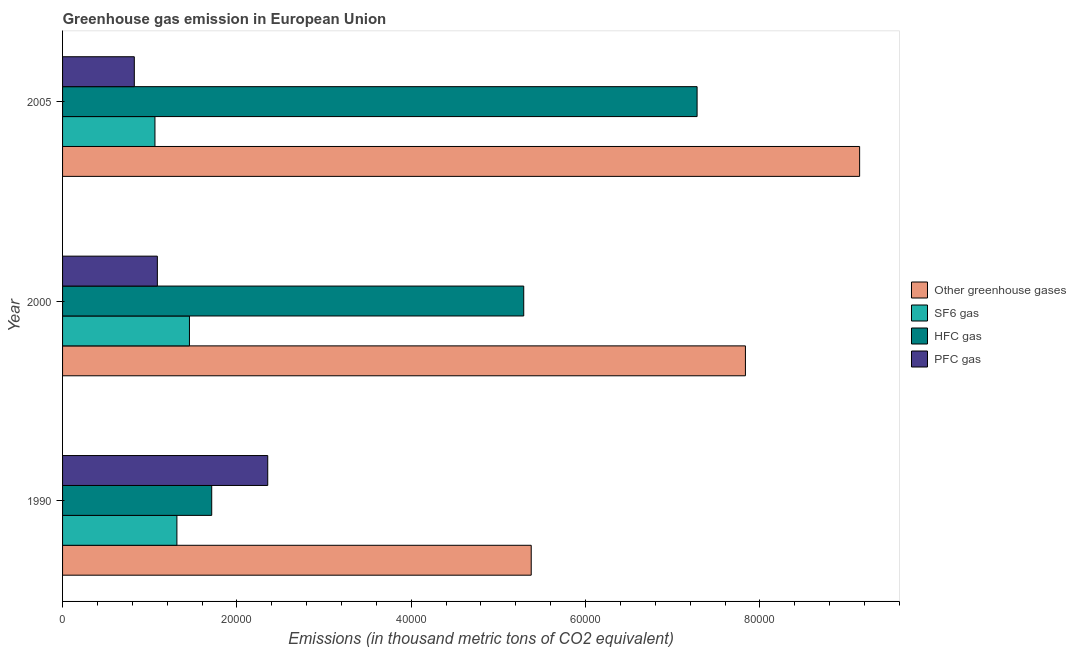How many different coloured bars are there?
Offer a very short reply. 4. Are the number of bars per tick equal to the number of legend labels?
Provide a short and direct response. Yes. Are the number of bars on each tick of the Y-axis equal?
Provide a short and direct response. Yes. What is the label of the 2nd group of bars from the top?
Provide a succinct answer. 2000. What is the emission of sf6 gas in 2005?
Keep it short and to the point. 1.06e+04. Across all years, what is the maximum emission of pfc gas?
Offer a very short reply. 2.35e+04. Across all years, what is the minimum emission of pfc gas?
Offer a terse response. 8230.79. In which year was the emission of hfc gas maximum?
Your answer should be very brief. 2005. In which year was the emission of greenhouse gases minimum?
Offer a terse response. 1990. What is the total emission of pfc gas in the graph?
Your answer should be very brief. 4.26e+04. What is the difference between the emission of pfc gas in 1990 and that in 2000?
Provide a short and direct response. 1.27e+04. What is the difference between the emission of hfc gas in 2000 and the emission of greenhouse gases in 1990?
Provide a short and direct response. -859.6. What is the average emission of pfc gas per year?
Make the answer very short. 1.42e+04. In the year 1990, what is the difference between the emission of hfc gas and emission of sf6 gas?
Your answer should be very brief. 3993.7. What is the ratio of the emission of pfc gas in 2000 to that in 2005?
Offer a very short reply. 1.32. What is the difference between the highest and the second highest emission of greenhouse gases?
Provide a short and direct response. 1.31e+04. What is the difference between the highest and the lowest emission of sf6 gas?
Your answer should be compact. 3958.08. Is it the case that in every year, the sum of the emission of greenhouse gases and emission of pfc gas is greater than the sum of emission of sf6 gas and emission of hfc gas?
Ensure brevity in your answer.  No. What does the 4th bar from the top in 2005 represents?
Your response must be concise. Other greenhouse gases. What does the 1st bar from the bottom in 2000 represents?
Ensure brevity in your answer.  Other greenhouse gases. Is it the case that in every year, the sum of the emission of greenhouse gases and emission of sf6 gas is greater than the emission of hfc gas?
Ensure brevity in your answer.  Yes. Are all the bars in the graph horizontal?
Provide a succinct answer. Yes. How many years are there in the graph?
Keep it short and to the point. 3. Does the graph contain grids?
Provide a succinct answer. No. How many legend labels are there?
Give a very brief answer. 4. How are the legend labels stacked?
Offer a very short reply. Vertical. What is the title of the graph?
Offer a terse response. Greenhouse gas emission in European Union. What is the label or title of the X-axis?
Your answer should be very brief. Emissions (in thousand metric tons of CO2 equivalent). What is the Emissions (in thousand metric tons of CO2 equivalent) in Other greenhouse gases in 1990?
Offer a terse response. 5.38e+04. What is the Emissions (in thousand metric tons of CO2 equivalent) in SF6 gas in 1990?
Your response must be concise. 1.31e+04. What is the Emissions (in thousand metric tons of CO2 equivalent) of HFC gas in 1990?
Your answer should be very brief. 1.71e+04. What is the Emissions (in thousand metric tons of CO2 equivalent) of PFC gas in 1990?
Provide a short and direct response. 2.35e+04. What is the Emissions (in thousand metric tons of CO2 equivalent) in Other greenhouse gases in 2000?
Your response must be concise. 7.83e+04. What is the Emissions (in thousand metric tons of CO2 equivalent) of SF6 gas in 2000?
Offer a terse response. 1.46e+04. What is the Emissions (in thousand metric tons of CO2 equivalent) in HFC gas in 2000?
Keep it short and to the point. 5.29e+04. What is the Emissions (in thousand metric tons of CO2 equivalent) in PFC gas in 2000?
Your answer should be very brief. 1.09e+04. What is the Emissions (in thousand metric tons of CO2 equivalent) of Other greenhouse gases in 2005?
Offer a very short reply. 9.14e+04. What is the Emissions (in thousand metric tons of CO2 equivalent) of SF6 gas in 2005?
Your response must be concise. 1.06e+04. What is the Emissions (in thousand metric tons of CO2 equivalent) of HFC gas in 2005?
Ensure brevity in your answer.  7.28e+04. What is the Emissions (in thousand metric tons of CO2 equivalent) of PFC gas in 2005?
Your answer should be compact. 8230.79. Across all years, what is the maximum Emissions (in thousand metric tons of CO2 equivalent) in Other greenhouse gases?
Provide a short and direct response. 9.14e+04. Across all years, what is the maximum Emissions (in thousand metric tons of CO2 equivalent) in SF6 gas?
Provide a succinct answer. 1.46e+04. Across all years, what is the maximum Emissions (in thousand metric tons of CO2 equivalent) of HFC gas?
Offer a very short reply. 7.28e+04. Across all years, what is the maximum Emissions (in thousand metric tons of CO2 equivalent) in PFC gas?
Keep it short and to the point. 2.35e+04. Across all years, what is the minimum Emissions (in thousand metric tons of CO2 equivalent) in Other greenhouse gases?
Give a very brief answer. 5.38e+04. Across all years, what is the minimum Emissions (in thousand metric tons of CO2 equivalent) of SF6 gas?
Your response must be concise. 1.06e+04. Across all years, what is the minimum Emissions (in thousand metric tons of CO2 equivalent) in HFC gas?
Your response must be concise. 1.71e+04. Across all years, what is the minimum Emissions (in thousand metric tons of CO2 equivalent) of PFC gas?
Provide a short and direct response. 8230.79. What is the total Emissions (in thousand metric tons of CO2 equivalent) of Other greenhouse gases in the graph?
Make the answer very short. 2.24e+05. What is the total Emissions (in thousand metric tons of CO2 equivalent) in SF6 gas in the graph?
Make the answer very short. 3.83e+04. What is the total Emissions (in thousand metric tons of CO2 equivalent) of HFC gas in the graph?
Ensure brevity in your answer.  1.43e+05. What is the total Emissions (in thousand metric tons of CO2 equivalent) of PFC gas in the graph?
Your answer should be very brief. 4.26e+04. What is the difference between the Emissions (in thousand metric tons of CO2 equivalent) in Other greenhouse gases in 1990 and that in 2000?
Provide a succinct answer. -2.46e+04. What is the difference between the Emissions (in thousand metric tons of CO2 equivalent) in SF6 gas in 1990 and that in 2000?
Your response must be concise. -1440.2. What is the difference between the Emissions (in thousand metric tons of CO2 equivalent) in HFC gas in 1990 and that in 2000?
Provide a succinct answer. -3.58e+04. What is the difference between the Emissions (in thousand metric tons of CO2 equivalent) in PFC gas in 1990 and that in 2000?
Make the answer very short. 1.27e+04. What is the difference between the Emissions (in thousand metric tons of CO2 equivalent) in Other greenhouse gases in 1990 and that in 2005?
Your answer should be compact. -3.77e+04. What is the difference between the Emissions (in thousand metric tons of CO2 equivalent) in SF6 gas in 1990 and that in 2005?
Provide a short and direct response. 2517.88. What is the difference between the Emissions (in thousand metric tons of CO2 equivalent) of HFC gas in 1990 and that in 2005?
Provide a succinct answer. -5.57e+04. What is the difference between the Emissions (in thousand metric tons of CO2 equivalent) of PFC gas in 1990 and that in 2005?
Your response must be concise. 1.53e+04. What is the difference between the Emissions (in thousand metric tons of CO2 equivalent) in Other greenhouse gases in 2000 and that in 2005?
Your answer should be compact. -1.31e+04. What is the difference between the Emissions (in thousand metric tons of CO2 equivalent) in SF6 gas in 2000 and that in 2005?
Give a very brief answer. 3958.08. What is the difference between the Emissions (in thousand metric tons of CO2 equivalent) in HFC gas in 2000 and that in 2005?
Provide a short and direct response. -1.99e+04. What is the difference between the Emissions (in thousand metric tons of CO2 equivalent) in PFC gas in 2000 and that in 2005?
Your answer should be compact. 2643.81. What is the difference between the Emissions (in thousand metric tons of CO2 equivalent) in Other greenhouse gases in 1990 and the Emissions (in thousand metric tons of CO2 equivalent) in SF6 gas in 2000?
Provide a short and direct response. 3.92e+04. What is the difference between the Emissions (in thousand metric tons of CO2 equivalent) of Other greenhouse gases in 1990 and the Emissions (in thousand metric tons of CO2 equivalent) of HFC gas in 2000?
Provide a succinct answer. 859.6. What is the difference between the Emissions (in thousand metric tons of CO2 equivalent) of Other greenhouse gases in 1990 and the Emissions (in thousand metric tons of CO2 equivalent) of PFC gas in 2000?
Your answer should be compact. 4.29e+04. What is the difference between the Emissions (in thousand metric tons of CO2 equivalent) of SF6 gas in 1990 and the Emissions (in thousand metric tons of CO2 equivalent) of HFC gas in 2000?
Offer a very short reply. -3.98e+04. What is the difference between the Emissions (in thousand metric tons of CO2 equivalent) of SF6 gas in 1990 and the Emissions (in thousand metric tons of CO2 equivalent) of PFC gas in 2000?
Offer a terse response. 2241.9. What is the difference between the Emissions (in thousand metric tons of CO2 equivalent) in HFC gas in 1990 and the Emissions (in thousand metric tons of CO2 equivalent) in PFC gas in 2000?
Your answer should be very brief. 6235.6. What is the difference between the Emissions (in thousand metric tons of CO2 equivalent) of Other greenhouse gases in 1990 and the Emissions (in thousand metric tons of CO2 equivalent) of SF6 gas in 2005?
Provide a short and direct response. 4.32e+04. What is the difference between the Emissions (in thousand metric tons of CO2 equivalent) of Other greenhouse gases in 1990 and the Emissions (in thousand metric tons of CO2 equivalent) of HFC gas in 2005?
Provide a succinct answer. -1.90e+04. What is the difference between the Emissions (in thousand metric tons of CO2 equivalent) in Other greenhouse gases in 1990 and the Emissions (in thousand metric tons of CO2 equivalent) in PFC gas in 2005?
Keep it short and to the point. 4.55e+04. What is the difference between the Emissions (in thousand metric tons of CO2 equivalent) in SF6 gas in 1990 and the Emissions (in thousand metric tons of CO2 equivalent) in HFC gas in 2005?
Offer a terse response. -5.97e+04. What is the difference between the Emissions (in thousand metric tons of CO2 equivalent) of SF6 gas in 1990 and the Emissions (in thousand metric tons of CO2 equivalent) of PFC gas in 2005?
Keep it short and to the point. 4885.71. What is the difference between the Emissions (in thousand metric tons of CO2 equivalent) of HFC gas in 1990 and the Emissions (in thousand metric tons of CO2 equivalent) of PFC gas in 2005?
Your response must be concise. 8879.41. What is the difference between the Emissions (in thousand metric tons of CO2 equivalent) in Other greenhouse gases in 2000 and the Emissions (in thousand metric tons of CO2 equivalent) in SF6 gas in 2005?
Make the answer very short. 6.77e+04. What is the difference between the Emissions (in thousand metric tons of CO2 equivalent) in Other greenhouse gases in 2000 and the Emissions (in thousand metric tons of CO2 equivalent) in HFC gas in 2005?
Make the answer very short. 5543.7. What is the difference between the Emissions (in thousand metric tons of CO2 equivalent) in Other greenhouse gases in 2000 and the Emissions (in thousand metric tons of CO2 equivalent) in PFC gas in 2005?
Make the answer very short. 7.01e+04. What is the difference between the Emissions (in thousand metric tons of CO2 equivalent) in SF6 gas in 2000 and the Emissions (in thousand metric tons of CO2 equivalent) in HFC gas in 2005?
Make the answer very short. -5.82e+04. What is the difference between the Emissions (in thousand metric tons of CO2 equivalent) in SF6 gas in 2000 and the Emissions (in thousand metric tons of CO2 equivalent) in PFC gas in 2005?
Your response must be concise. 6325.91. What is the difference between the Emissions (in thousand metric tons of CO2 equivalent) of HFC gas in 2000 and the Emissions (in thousand metric tons of CO2 equivalent) of PFC gas in 2005?
Provide a short and direct response. 4.47e+04. What is the average Emissions (in thousand metric tons of CO2 equivalent) in Other greenhouse gases per year?
Provide a short and direct response. 7.45e+04. What is the average Emissions (in thousand metric tons of CO2 equivalent) of SF6 gas per year?
Your answer should be very brief. 1.28e+04. What is the average Emissions (in thousand metric tons of CO2 equivalent) in HFC gas per year?
Provide a short and direct response. 4.76e+04. What is the average Emissions (in thousand metric tons of CO2 equivalent) of PFC gas per year?
Offer a terse response. 1.42e+04. In the year 1990, what is the difference between the Emissions (in thousand metric tons of CO2 equivalent) of Other greenhouse gases and Emissions (in thousand metric tons of CO2 equivalent) of SF6 gas?
Provide a short and direct response. 4.06e+04. In the year 1990, what is the difference between the Emissions (in thousand metric tons of CO2 equivalent) of Other greenhouse gases and Emissions (in thousand metric tons of CO2 equivalent) of HFC gas?
Ensure brevity in your answer.  3.67e+04. In the year 1990, what is the difference between the Emissions (in thousand metric tons of CO2 equivalent) of Other greenhouse gases and Emissions (in thousand metric tons of CO2 equivalent) of PFC gas?
Provide a succinct answer. 3.02e+04. In the year 1990, what is the difference between the Emissions (in thousand metric tons of CO2 equivalent) in SF6 gas and Emissions (in thousand metric tons of CO2 equivalent) in HFC gas?
Provide a short and direct response. -3993.7. In the year 1990, what is the difference between the Emissions (in thousand metric tons of CO2 equivalent) of SF6 gas and Emissions (in thousand metric tons of CO2 equivalent) of PFC gas?
Your answer should be very brief. -1.04e+04. In the year 1990, what is the difference between the Emissions (in thousand metric tons of CO2 equivalent) in HFC gas and Emissions (in thousand metric tons of CO2 equivalent) in PFC gas?
Provide a short and direct response. -6426.3. In the year 2000, what is the difference between the Emissions (in thousand metric tons of CO2 equivalent) of Other greenhouse gases and Emissions (in thousand metric tons of CO2 equivalent) of SF6 gas?
Make the answer very short. 6.38e+04. In the year 2000, what is the difference between the Emissions (in thousand metric tons of CO2 equivalent) in Other greenhouse gases and Emissions (in thousand metric tons of CO2 equivalent) in HFC gas?
Your response must be concise. 2.54e+04. In the year 2000, what is the difference between the Emissions (in thousand metric tons of CO2 equivalent) in Other greenhouse gases and Emissions (in thousand metric tons of CO2 equivalent) in PFC gas?
Offer a terse response. 6.75e+04. In the year 2000, what is the difference between the Emissions (in thousand metric tons of CO2 equivalent) of SF6 gas and Emissions (in thousand metric tons of CO2 equivalent) of HFC gas?
Provide a succinct answer. -3.83e+04. In the year 2000, what is the difference between the Emissions (in thousand metric tons of CO2 equivalent) of SF6 gas and Emissions (in thousand metric tons of CO2 equivalent) of PFC gas?
Give a very brief answer. 3682.1. In the year 2000, what is the difference between the Emissions (in thousand metric tons of CO2 equivalent) of HFC gas and Emissions (in thousand metric tons of CO2 equivalent) of PFC gas?
Give a very brief answer. 4.20e+04. In the year 2005, what is the difference between the Emissions (in thousand metric tons of CO2 equivalent) of Other greenhouse gases and Emissions (in thousand metric tons of CO2 equivalent) of SF6 gas?
Give a very brief answer. 8.08e+04. In the year 2005, what is the difference between the Emissions (in thousand metric tons of CO2 equivalent) in Other greenhouse gases and Emissions (in thousand metric tons of CO2 equivalent) in HFC gas?
Provide a succinct answer. 1.86e+04. In the year 2005, what is the difference between the Emissions (in thousand metric tons of CO2 equivalent) of Other greenhouse gases and Emissions (in thousand metric tons of CO2 equivalent) of PFC gas?
Keep it short and to the point. 8.32e+04. In the year 2005, what is the difference between the Emissions (in thousand metric tons of CO2 equivalent) of SF6 gas and Emissions (in thousand metric tons of CO2 equivalent) of HFC gas?
Your response must be concise. -6.22e+04. In the year 2005, what is the difference between the Emissions (in thousand metric tons of CO2 equivalent) in SF6 gas and Emissions (in thousand metric tons of CO2 equivalent) in PFC gas?
Your answer should be very brief. 2367.83. In the year 2005, what is the difference between the Emissions (in thousand metric tons of CO2 equivalent) of HFC gas and Emissions (in thousand metric tons of CO2 equivalent) of PFC gas?
Make the answer very short. 6.46e+04. What is the ratio of the Emissions (in thousand metric tons of CO2 equivalent) of Other greenhouse gases in 1990 to that in 2000?
Offer a very short reply. 0.69. What is the ratio of the Emissions (in thousand metric tons of CO2 equivalent) of SF6 gas in 1990 to that in 2000?
Offer a terse response. 0.9. What is the ratio of the Emissions (in thousand metric tons of CO2 equivalent) of HFC gas in 1990 to that in 2000?
Provide a short and direct response. 0.32. What is the ratio of the Emissions (in thousand metric tons of CO2 equivalent) in PFC gas in 1990 to that in 2000?
Provide a succinct answer. 2.16. What is the ratio of the Emissions (in thousand metric tons of CO2 equivalent) in Other greenhouse gases in 1990 to that in 2005?
Offer a very short reply. 0.59. What is the ratio of the Emissions (in thousand metric tons of CO2 equivalent) in SF6 gas in 1990 to that in 2005?
Your answer should be compact. 1.24. What is the ratio of the Emissions (in thousand metric tons of CO2 equivalent) in HFC gas in 1990 to that in 2005?
Provide a short and direct response. 0.24. What is the ratio of the Emissions (in thousand metric tons of CO2 equivalent) of PFC gas in 1990 to that in 2005?
Ensure brevity in your answer.  2.86. What is the ratio of the Emissions (in thousand metric tons of CO2 equivalent) in Other greenhouse gases in 2000 to that in 2005?
Offer a terse response. 0.86. What is the ratio of the Emissions (in thousand metric tons of CO2 equivalent) of SF6 gas in 2000 to that in 2005?
Your answer should be compact. 1.37. What is the ratio of the Emissions (in thousand metric tons of CO2 equivalent) in HFC gas in 2000 to that in 2005?
Offer a terse response. 0.73. What is the ratio of the Emissions (in thousand metric tons of CO2 equivalent) in PFC gas in 2000 to that in 2005?
Give a very brief answer. 1.32. What is the difference between the highest and the second highest Emissions (in thousand metric tons of CO2 equivalent) of Other greenhouse gases?
Make the answer very short. 1.31e+04. What is the difference between the highest and the second highest Emissions (in thousand metric tons of CO2 equivalent) in SF6 gas?
Your answer should be compact. 1440.2. What is the difference between the highest and the second highest Emissions (in thousand metric tons of CO2 equivalent) of HFC gas?
Make the answer very short. 1.99e+04. What is the difference between the highest and the second highest Emissions (in thousand metric tons of CO2 equivalent) in PFC gas?
Offer a very short reply. 1.27e+04. What is the difference between the highest and the lowest Emissions (in thousand metric tons of CO2 equivalent) of Other greenhouse gases?
Offer a terse response. 3.77e+04. What is the difference between the highest and the lowest Emissions (in thousand metric tons of CO2 equivalent) of SF6 gas?
Give a very brief answer. 3958.08. What is the difference between the highest and the lowest Emissions (in thousand metric tons of CO2 equivalent) of HFC gas?
Provide a short and direct response. 5.57e+04. What is the difference between the highest and the lowest Emissions (in thousand metric tons of CO2 equivalent) of PFC gas?
Provide a short and direct response. 1.53e+04. 